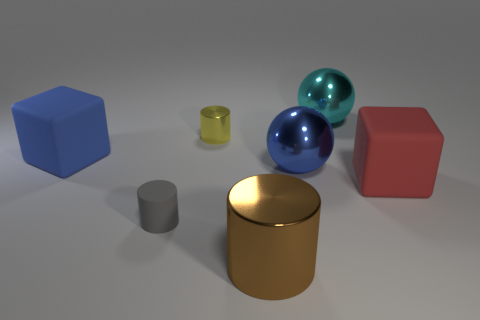There is a big matte object that is behind the large block that is on the right side of the big blue thing that is on the left side of the matte cylinder; what shape is it?
Offer a terse response. Cube. There is a cyan object; how many big red rubber things are on the left side of it?
Offer a very short reply. 0. Does the big thing on the left side of the tiny gray rubber object have the same material as the tiny gray cylinder?
Provide a succinct answer. Yes. How many other objects are there of the same shape as the blue metallic object?
Your answer should be very brief. 1. What number of blue metal things are on the left side of the matte cube in front of the blue cube in front of the tiny yellow shiny cylinder?
Provide a succinct answer. 1. What color is the matte thing left of the gray object?
Your response must be concise. Blue. Do the cube in front of the blue matte object and the rubber cylinder have the same color?
Ensure brevity in your answer.  No. What is the size of the other matte object that is the same shape as the blue matte object?
Your answer should be compact. Large. Is there any other thing that has the same size as the brown cylinder?
Keep it short and to the point. Yes. There is a block that is to the right of the rubber block that is left of the rubber cube in front of the blue block; what is it made of?
Make the answer very short. Rubber. 